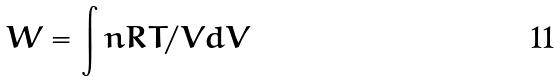<formula> <loc_0><loc_0><loc_500><loc_500>W = \int n R T / V d V</formula> 